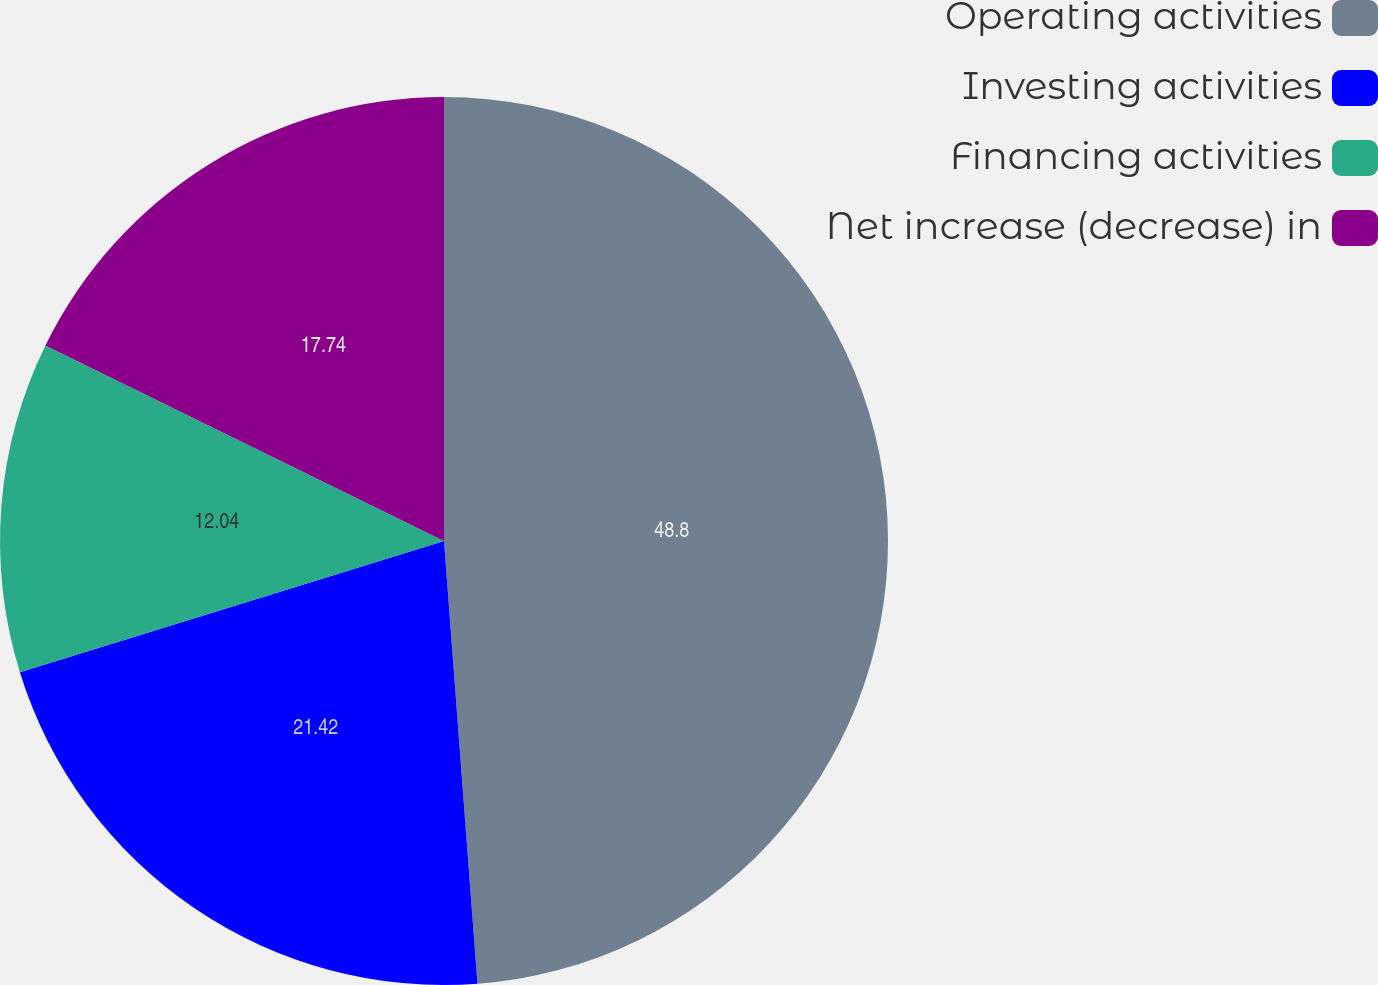<chart> <loc_0><loc_0><loc_500><loc_500><pie_chart><fcel>Operating activities<fcel>Investing activities<fcel>Financing activities<fcel>Net increase (decrease) in<nl><fcel>48.8%<fcel>21.42%<fcel>12.04%<fcel>17.74%<nl></chart> 